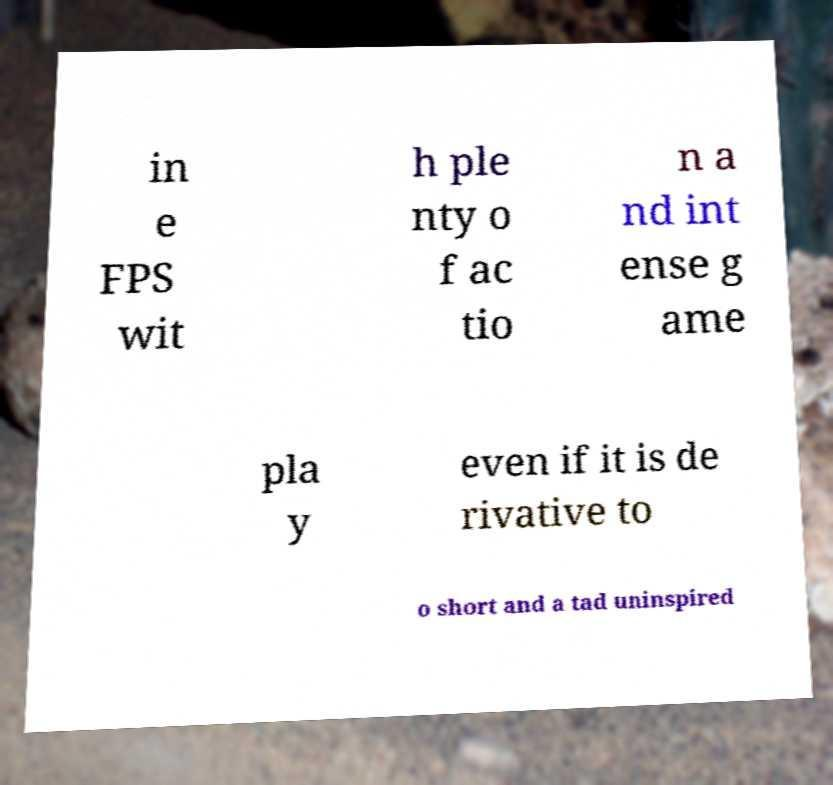What messages or text are displayed in this image? I need them in a readable, typed format. in e FPS wit h ple nty o f ac tio n a nd int ense g ame pla y even if it is de rivative to o short and a tad uninspired 